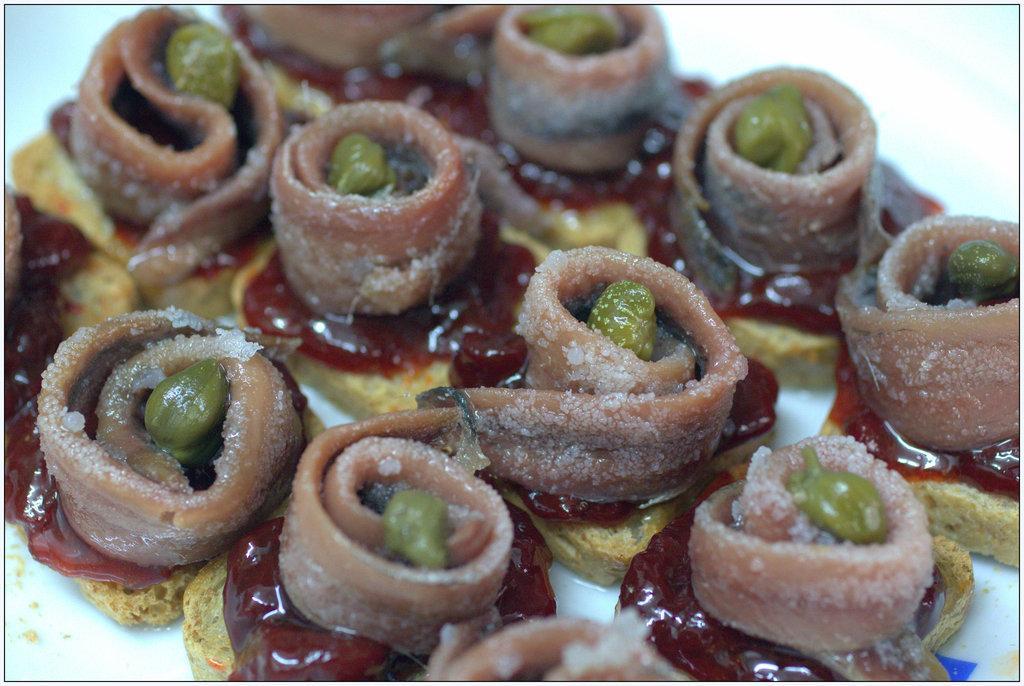In one or two sentences, can you explain what this image depicts? In this picture we can see some food item is present on a plate. 